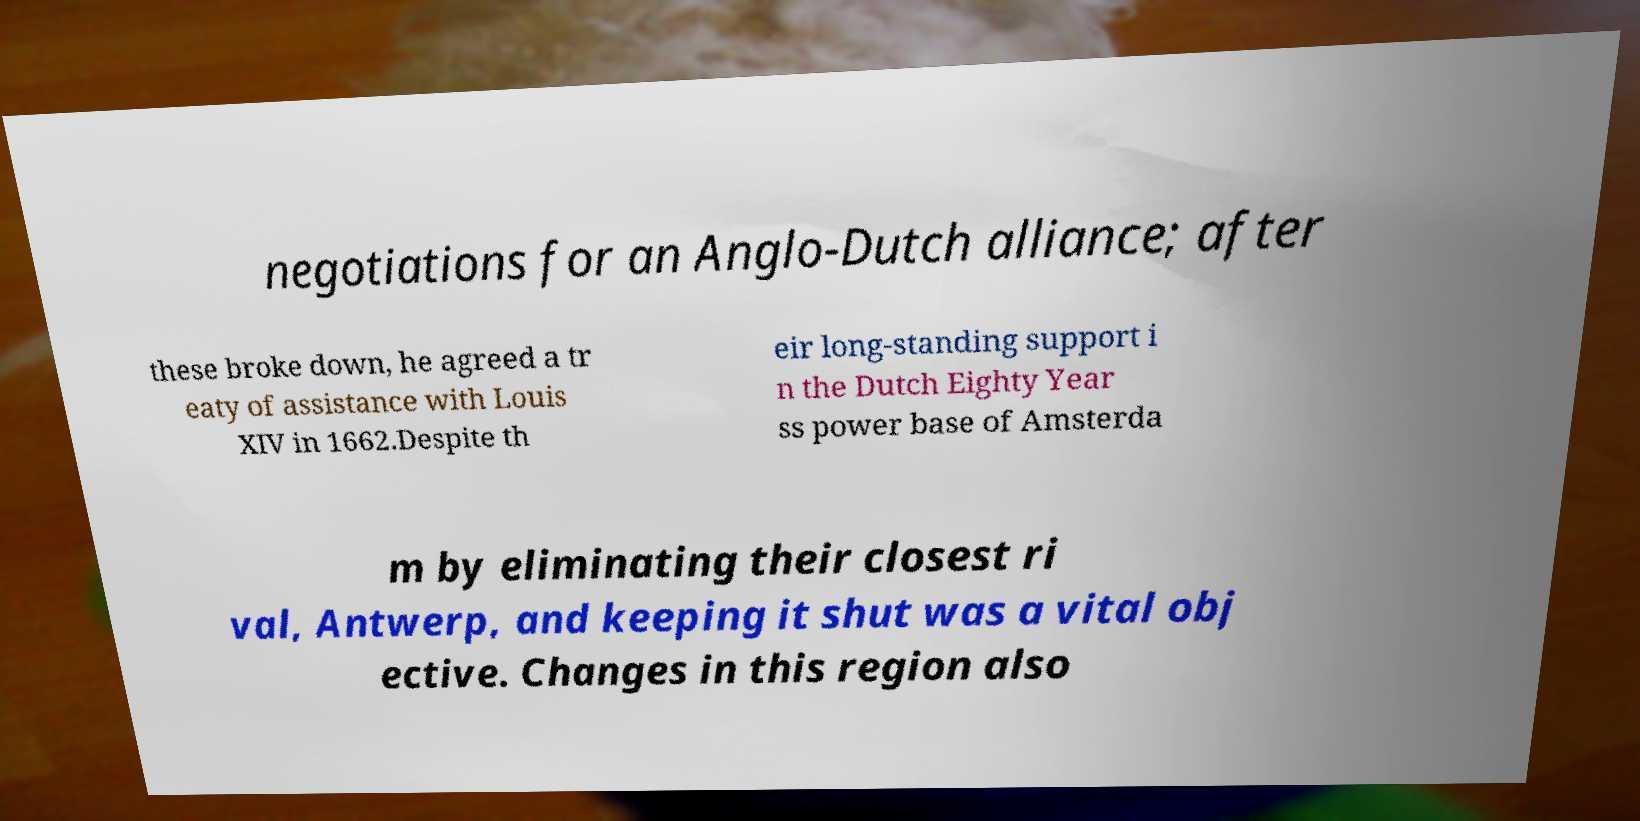For documentation purposes, I need the text within this image transcribed. Could you provide that? negotiations for an Anglo-Dutch alliance; after these broke down, he agreed a tr eaty of assistance with Louis XIV in 1662.Despite th eir long-standing support i n the Dutch Eighty Year ss power base of Amsterda m by eliminating their closest ri val, Antwerp, and keeping it shut was a vital obj ective. Changes in this region also 